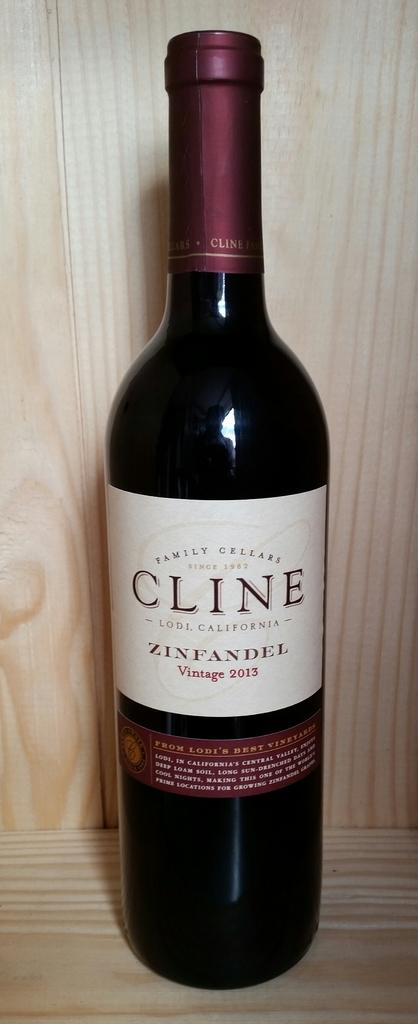<image>
Write a terse but informative summary of the picture. A dark bottle of Cline Zinfandel is on a wooden shelf. 